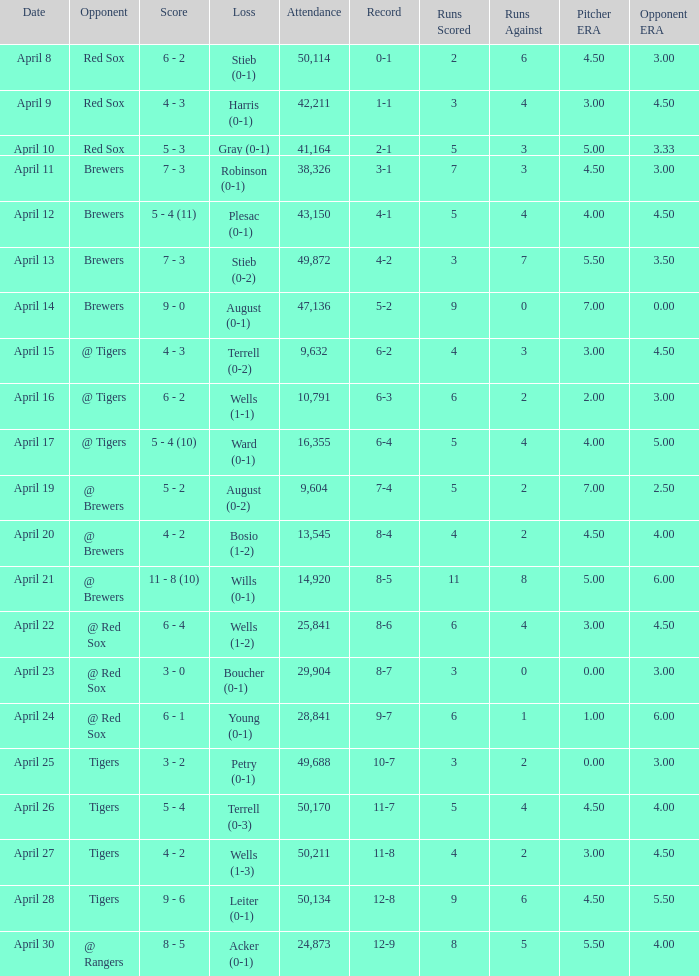Which loss has an attendance greater than 49,688 and 11-8 as the record? Wells (1-3). 